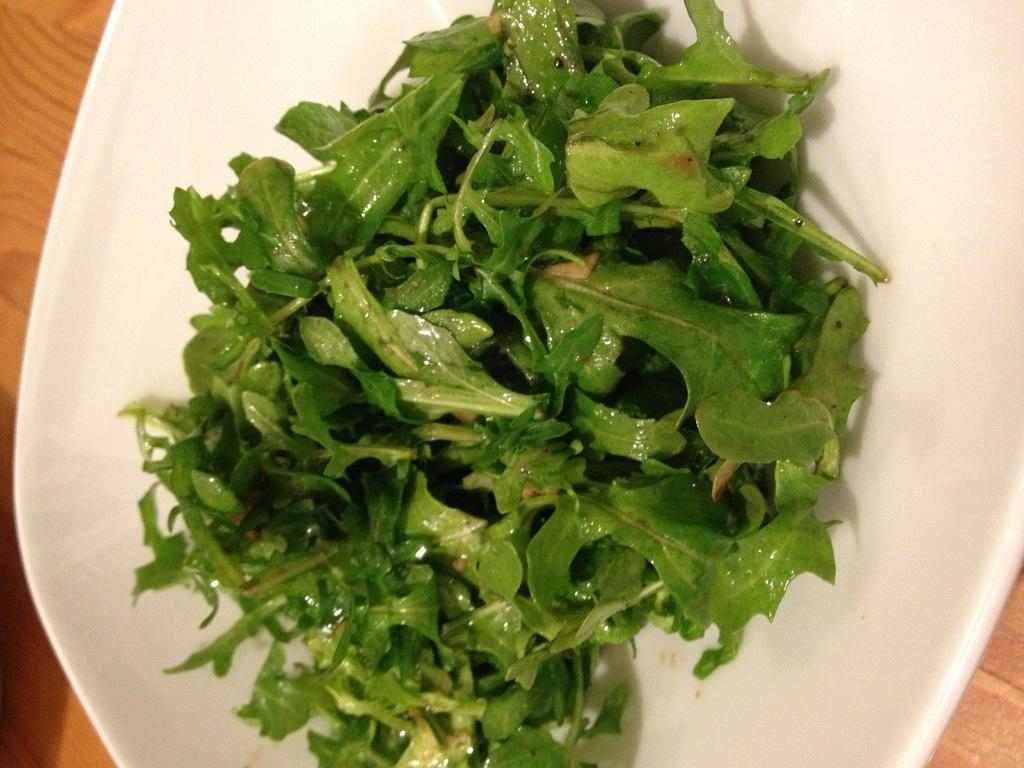What type of food is on the plate in the image? There are spring greens on a plate in the image. Where is the plate located? The plate is present on a table. What is the best way to use the foot to access the property in the image? There is no mention of a foot or property in the image, so this question cannot be answered based on the provided facts. 